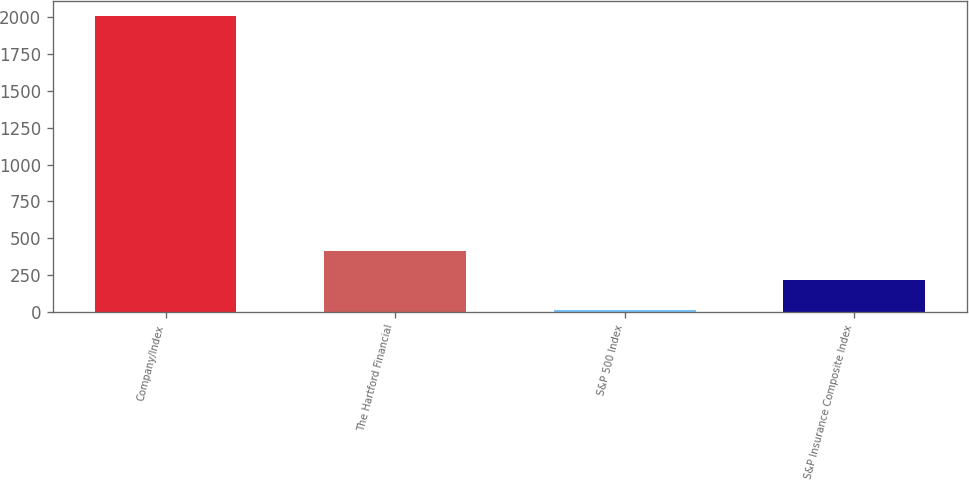Convert chart. <chart><loc_0><loc_0><loc_500><loc_500><bar_chart><fcel>Company/Index<fcel>The Hartford Financial<fcel>S&P 500 Index<fcel>S&P Insurance Composite Index<nl><fcel>2012<fcel>415.2<fcel>16<fcel>215.6<nl></chart> 